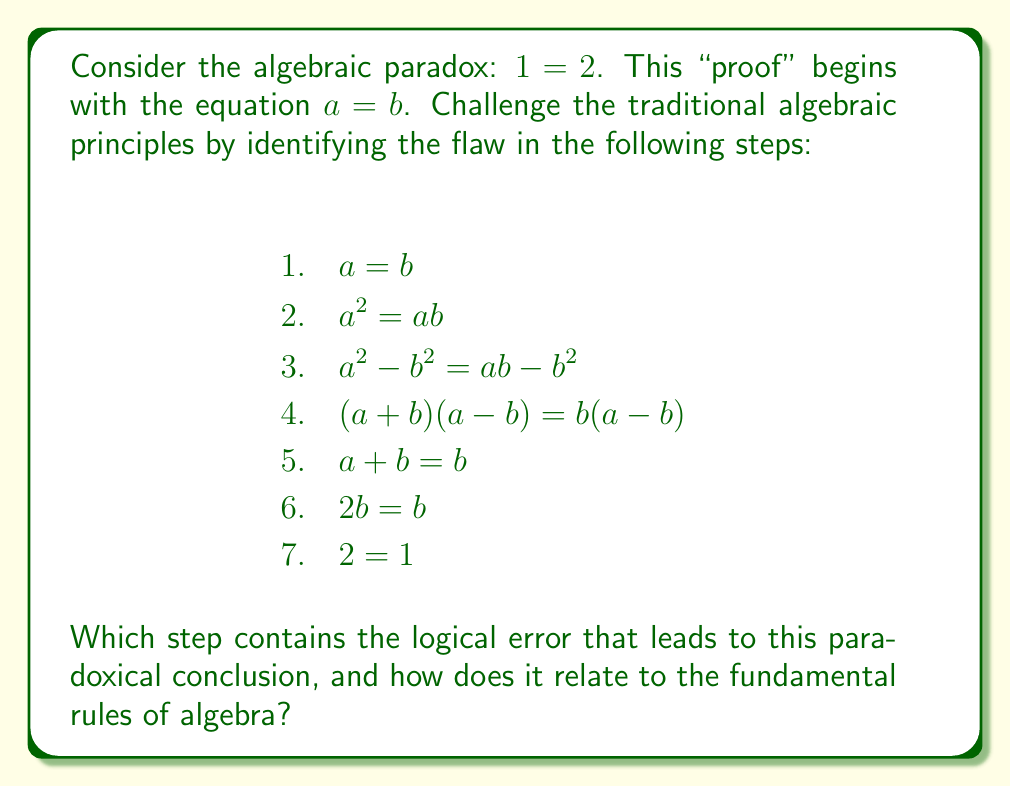Provide a solution to this math problem. Let's analyze this paradox step by step:

1. We start with the assumption $a = b$.
2. Multiply both sides by $a$: $a^2 = ab$. This step is valid.
3. Subtract $b^2$ from both sides: $a^2 - b^2 = ab - b^2$. This step is valid.
4. Factor the left side: $(a+b)(a-b) = b(a-b)$. This step is valid.
5. Divide both sides by $(a-b)$: $a + b = b$. This is where the error occurs.

The error in step 5 is dividing by $(a-b)$. Since we started with the assumption that $a = b$, it follows that $a - b = 0$. Dividing by zero is undefined in algebra and leads to paradoxical results.

To see why this is problematic, let's consider the equation:

$$(a-b)(a+b) = (a-b)b$$

If $a = b$, then $a - b = 0$, and our equation becomes:

$$0 \cdot (a+b) = 0 \cdot b$$

This is true for any value of $a$ and $b$, not just when $a + b = b$.

This paradox highlights the importance of the rule that we cannot divide by zero in algebra. It also demonstrates how a seemingly innocuous step in algebraic manipulation can lead to absurd conclusions if we're not careful about the conditions under which our operations are valid.

By questioning this traditional algebraic "proof," we uncover a fundamental principle: the need to check for division by zero when simplifying algebraic expressions or solving equations.
Answer: Step 5: division by $(a-b)$, which equals zero 